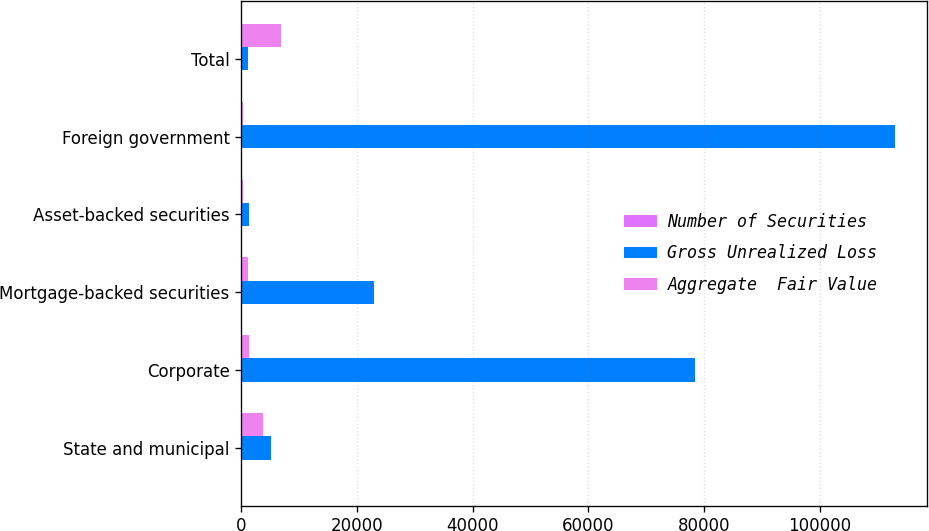<chart> <loc_0><loc_0><loc_500><loc_500><stacked_bar_chart><ecel><fcel>State and municipal<fcel>Corporate<fcel>Mortgage-backed securities<fcel>Asset-backed securities<fcel>Foreign government<fcel>Total<nl><fcel>Number of Securities<fcel>1<fcel>10<fcel>11<fcel>4<fcel>15<fcel>41<nl><fcel>Gross Unrealized Loss<fcel>5136<fcel>78462<fcel>22987<fcel>1256<fcel>112985<fcel>1106<nl><fcel>Aggregate  Fair Value<fcel>3725<fcel>1370<fcel>1106<fcel>362<fcel>341<fcel>6904<nl></chart> 